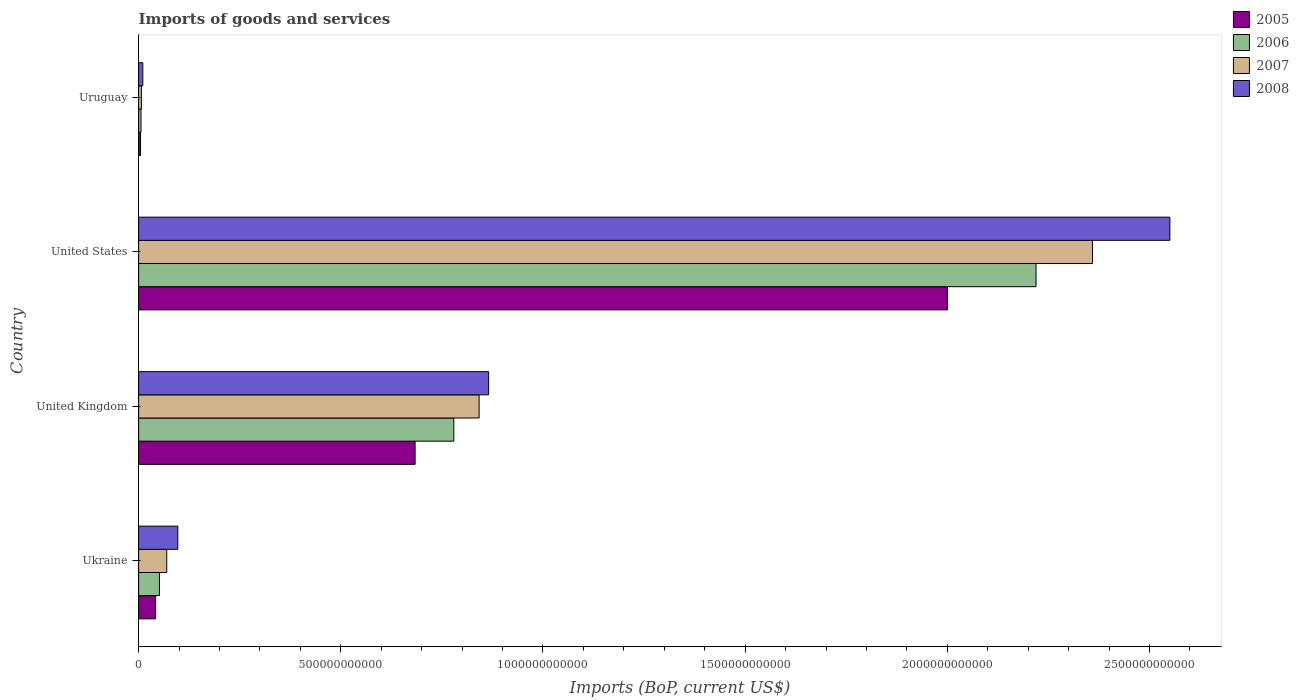How many different coloured bars are there?
Your response must be concise. 4. How many groups of bars are there?
Ensure brevity in your answer.  4. Are the number of bars on each tick of the Y-axis equal?
Your response must be concise. Yes. How many bars are there on the 1st tick from the bottom?
Your response must be concise. 4. What is the label of the 4th group of bars from the top?
Provide a succinct answer. Ukraine. What is the amount spent on imports in 2008 in United States?
Give a very brief answer. 2.55e+12. Across all countries, what is the maximum amount spent on imports in 2005?
Keep it short and to the point. 2.00e+12. Across all countries, what is the minimum amount spent on imports in 2005?
Keep it short and to the point. 4.69e+09. In which country was the amount spent on imports in 2007 maximum?
Your response must be concise. United States. In which country was the amount spent on imports in 2005 minimum?
Give a very brief answer. Uruguay. What is the total amount spent on imports in 2006 in the graph?
Give a very brief answer. 3.06e+12. What is the difference between the amount spent on imports in 2005 in United Kingdom and that in Uruguay?
Give a very brief answer. 6.79e+11. What is the difference between the amount spent on imports in 2005 in United States and the amount spent on imports in 2006 in Uruguay?
Your answer should be compact. 1.99e+12. What is the average amount spent on imports in 2006 per country?
Your answer should be compact. 7.64e+11. What is the difference between the amount spent on imports in 2005 and amount spent on imports in 2006 in Uruguay?
Your answer should be compact. -1.18e+09. What is the ratio of the amount spent on imports in 2005 in Ukraine to that in United States?
Keep it short and to the point. 0.02. What is the difference between the highest and the second highest amount spent on imports in 2006?
Provide a succinct answer. 1.44e+12. What is the difference between the highest and the lowest amount spent on imports in 2007?
Your answer should be compact. 2.35e+12. In how many countries, is the amount spent on imports in 2007 greater than the average amount spent on imports in 2007 taken over all countries?
Offer a terse response. 2. What does the 4th bar from the bottom in Ukraine represents?
Your response must be concise. 2008. Is it the case that in every country, the sum of the amount spent on imports in 2005 and amount spent on imports in 2008 is greater than the amount spent on imports in 2007?
Ensure brevity in your answer.  Yes. Are all the bars in the graph horizontal?
Your answer should be compact. Yes. How many countries are there in the graph?
Offer a terse response. 4. What is the difference between two consecutive major ticks on the X-axis?
Your answer should be very brief. 5.00e+11. Are the values on the major ticks of X-axis written in scientific E-notation?
Make the answer very short. No. How many legend labels are there?
Provide a succinct answer. 4. How are the legend labels stacked?
Your answer should be compact. Vertical. What is the title of the graph?
Your answer should be very brief. Imports of goods and services. What is the label or title of the X-axis?
Offer a terse response. Imports (BoP, current US$). What is the label or title of the Y-axis?
Your response must be concise. Country. What is the Imports (BoP, current US$) in 2005 in Ukraine?
Your answer should be compact. 4.20e+1. What is the Imports (BoP, current US$) in 2006 in Ukraine?
Provide a succinct answer. 5.14e+1. What is the Imports (BoP, current US$) in 2007 in Ukraine?
Keep it short and to the point. 6.95e+1. What is the Imports (BoP, current US$) of 2008 in Ukraine?
Provide a short and direct response. 9.68e+1. What is the Imports (BoP, current US$) of 2005 in United Kingdom?
Offer a very short reply. 6.84e+11. What is the Imports (BoP, current US$) in 2006 in United Kingdom?
Offer a very short reply. 7.80e+11. What is the Imports (BoP, current US$) of 2007 in United Kingdom?
Offer a terse response. 8.42e+11. What is the Imports (BoP, current US$) in 2008 in United Kingdom?
Provide a short and direct response. 8.66e+11. What is the Imports (BoP, current US$) of 2005 in United States?
Provide a succinct answer. 2.00e+12. What is the Imports (BoP, current US$) of 2006 in United States?
Give a very brief answer. 2.22e+12. What is the Imports (BoP, current US$) in 2007 in United States?
Provide a short and direct response. 2.36e+12. What is the Imports (BoP, current US$) of 2008 in United States?
Offer a very short reply. 2.55e+12. What is the Imports (BoP, current US$) in 2005 in Uruguay?
Ensure brevity in your answer.  4.69e+09. What is the Imports (BoP, current US$) in 2006 in Uruguay?
Offer a terse response. 5.88e+09. What is the Imports (BoP, current US$) of 2007 in Uruguay?
Keep it short and to the point. 6.78e+09. What is the Imports (BoP, current US$) in 2008 in Uruguay?
Provide a short and direct response. 1.03e+1. Across all countries, what is the maximum Imports (BoP, current US$) in 2005?
Your answer should be compact. 2.00e+12. Across all countries, what is the maximum Imports (BoP, current US$) of 2006?
Your answer should be very brief. 2.22e+12. Across all countries, what is the maximum Imports (BoP, current US$) in 2007?
Offer a terse response. 2.36e+12. Across all countries, what is the maximum Imports (BoP, current US$) in 2008?
Your answer should be compact. 2.55e+12. Across all countries, what is the minimum Imports (BoP, current US$) of 2005?
Your answer should be compact. 4.69e+09. Across all countries, what is the minimum Imports (BoP, current US$) in 2006?
Give a very brief answer. 5.88e+09. Across all countries, what is the minimum Imports (BoP, current US$) in 2007?
Your response must be concise. 6.78e+09. Across all countries, what is the minimum Imports (BoP, current US$) in 2008?
Provide a short and direct response. 1.03e+1. What is the total Imports (BoP, current US$) in 2005 in the graph?
Your answer should be very brief. 2.73e+12. What is the total Imports (BoP, current US$) in 2006 in the graph?
Offer a very short reply. 3.06e+12. What is the total Imports (BoP, current US$) of 2007 in the graph?
Provide a succinct answer. 3.28e+12. What is the total Imports (BoP, current US$) of 2008 in the graph?
Offer a terse response. 3.52e+12. What is the difference between the Imports (BoP, current US$) of 2005 in Ukraine and that in United Kingdom?
Keep it short and to the point. -6.42e+11. What is the difference between the Imports (BoP, current US$) of 2006 in Ukraine and that in United Kingdom?
Give a very brief answer. -7.28e+11. What is the difference between the Imports (BoP, current US$) of 2007 in Ukraine and that in United Kingdom?
Give a very brief answer. -7.72e+11. What is the difference between the Imports (BoP, current US$) of 2008 in Ukraine and that in United Kingdom?
Keep it short and to the point. -7.69e+11. What is the difference between the Imports (BoP, current US$) in 2005 in Ukraine and that in United States?
Offer a very short reply. -1.96e+12. What is the difference between the Imports (BoP, current US$) of 2006 in Ukraine and that in United States?
Offer a terse response. -2.17e+12. What is the difference between the Imports (BoP, current US$) in 2007 in Ukraine and that in United States?
Provide a succinct answer. -2.29e+12. What is the difference between the Imports (BoP, current US$) of 2008 in Ukraine and that in United States?
Give a very brief answer. -2.45e+12. What is the difference between the Imports (BoP, current US$) of 2005 in Ukraine and that in Uruguay?
Provide a succinct answer. 3.73e+1. What is the difference between the Imports (BoP, current US$) in 2006 in Ukraine and that in Uruguay?
Make the answer very short. 4.55e+1. What is the difference between the Imports (BoP, current US$) in 2007 in Ukraine and that in Uruguay?
Ensure brevity in your answer.  6.28e+1. What is the difference between the Imports (BoP, current US$) in 2008 in Ukraine and that in Uruguay?
Your response must be concise. 8.65e+1. What is the difference between the Imports (BoP, current US$) of 2005 in United Kingdom and that in United States?
Your answer should be very brief. -1.32e+12. What is the difference between the Imports (BoP, current US$) in 2006 in United Kingdom and that in United States?
Provide a succinct answer. -1.44e+12. What is the difference between the Imports (BoP, current US$) of 2007 in United Kingdom and that in United States?
Offer a very short reply. -1.52e+12. What is the difference between the Imports (BoP, current US$) in 2008 in United Kingdom and that in United States?
Offer a terse response. -1.68e+12. What is the difference between the Imports (BoP, current US$) in 2005 in United Kingdom and that in Uruguay?
Keep it short and to the point. 6.79e+11. What is the difference between the Imports (BoP, current US$) of 2006 in United Kingdom and that in Uruguay?
Provide a succinct answer. 7.74e+11. What is the difference between the Imports (BoP, current US$) of 2007 in United Kingdom and that in Uruguay?
Offer a very short reply. 8.35e+11. What is the difference between the Imports (BoP, current US$) in 2008 in United Kingdom and that in Uruguay?
Offer a terse response. 8.55e+11. What is the difference between the Imports (BoP, current US$) in 2005 in United States and that in Uruguay?
Provide a succinct answer. 2.00e+12. What is the difference between the Imports (BoP, current US$) in 2006 in United States and that in Uruguay?
Your answer should be very brief. 2.21e+12. What is the difference between the Imports (BoP, current US$) in 2007 in United States and that in Uruguay?
Keep it short and to the point. 2.35e+12. What is the difference between the Imports (BoP, current US$) in 2008 in United States and that in Uruguay?
Provide a short and direct response. 2.54e+12. What is the difference between the Imports (BoP, current US$) in 2005 in Ukraine and the Imports (BoP, current US$) in 2006 in United Kingdom?
Make the answer very short. -7.38e+11. What is the difference between the Imports (BoP, current US$) in 2005 in Ukraine and the Imports (BoP, current US$) in 2007 in United Kingdom?
Offer a terse response. -8.00e+11. What is the difference between the Imports (BoP, current US$) in 2005 in Ukraine and the Imports (BoP, current US$) in 2008 in United Kingdom?
Offer a very short reply. -8.24e+11. What is the difference between the Imports (BoP, current US$) of 2006 in Ukraine and the Imports (BoP, current US$) of 2007 in United Kingdom?
Offer a terse response. -7.91e+11. What is the difference between the Imports (BoP, current US$) of 2006 in Ukraine and the Imports (BoP, current US$) of 2008 in United Kingdom?
Your answer should be compact. -8.14e+11. What is the difference between the Imports (BoP, current US$) of 2007 in Ukraine and the Imports (BoP, current US$) of 2008 in United Kingdom?
Offer a terse response. -7.96e+11. What is the difference between the Imports (BoP, current US$) in 2005 in Ukraine and the Imports (BoP, current US$) in 2006 in United States?
Give a very brief answer. -2.18e+12. What is the difference between the Imports (BoP, current US$) of 2005 in Ukraine and the Imports (BoP, current US$) of 2007 in United States?
Give a very brief answer. -2.32e+12. What is the difference between the Imports (BoP, current US$) in 2005 in Ukraine and the Imports (BoP, current US$) in 2008 in United States?
Give a very brief answer. -2.51e+12. What is the difference between the Imports (BoP, current US$) of 2006 in Ukraine and the Imports (BoP, current US$) of 2007 in United States?
Provide a short and direct response. -2.31e+12. What is the difference between the Imports (BoP, current US$) in 2006 in Ukraine and the Imports (BoP, current US$) in 2008 in United States?
Your response must be concise. -2.50e+12. What is the difference between the Imports (BoP, current US$) in 2007 in Ukraine and the Imports (BoP, current US$) in 2008 in United States?
Ensure brevity in your answer.  -2.48e+12. What is the difference between the Imports (BoP, current US$) of 2005 in Ukraine and the Imports (BoP, current US$) of 2006 in Uruguay?
Offer a very short reply. 3.61e+1. What is the difference between the Imports (BoP, current US$) in 2005 in Ukraine and the Imports (BoP, current US$) in 2007 in Uruguay?
Offer a very short reply. 3.52e+1. What is the difference between the Imports (BoP, current US$) of 2005 in Ukraine and the Imports (BoP, current US$) of 2008 in Uruguay?
Your response must be concise. 3.16e+1. What is the difference between the Imports (BoP, current US$) of 2006 in Ukraine and the Imports (BoP, current US$) of 2007 in Uruguay?
Provide a succinct answer. 4.46e+1. What is the difference between the Imports (BoP, current US$) in 2006 in Ukraine and the Imports (BoP, current US$) in 2008 in Uruguay?
Your answer should be very brief. 4.11e+1. What is the difference between the Imports (BoP, current US$) of 2007 in Ukraine and the Imports (BoP, current US$) of 2008 in Uruguay?
Your answer should be very brief. 5.92e+1. What is the difference between the Imports (BoP, current US$) in 2005 in United Kingdom and the Imports (BoP, current US$) in 2006 in United States?
Make the answer very short. -1.54e+12. What is the difference between the Imports (BoP, current US$) of 2005 in United Kingdom and the Imports (BoP, current US$) of 2007 in United States?
Offer a very short reply. -1.68e+12. What is the difference between the Imports (BoP, current US$) in 2005 in United Kingdom and the Imports (BoP, current US$) in 2008 in United States?
Provide a short and direct response. -1.87e+12. What is the difference between the Imports (BoP, current US$) in 2006 in United Kingdom and the Imports (BoP, current US$) in 2007 in United States?
Your answer should be very brief. -1.58e+12. What is the difference between the Imports (BoP, current US$) of 2006 in United Kingdom and the Imports (BoP, current US$) of 2008 in United States?
Offer a terse response. -1.77e+12. What is the difference between the Imports (BoP, current US$) of 2007 in United Kingdom and the Imports (BoP, current US$) of 2008 in United States?
Keep it short and to the point. -1.71e+12. What is the difference between the Imports (BoP, current US$) of 2005 in United Kingdom and the Imports (BoP, current US$) of 2006 in Uruguay?
Provide a succinct answer. 6.78e+11. What is the difference between the Imports (BoP, current US$) in 2005 in United Kingdom and the Imports (BoP, current US$) in 2007 in Uruguay?
Offer a very short reply. 6.77e+11. What is the difference between the Imports (BoP, current US$) in 2005 in United Kingdom and the Imports (BoP, current US$) in 2008 in Uruguay?
Your response must be concise. 6.73e+11. What is the difference between the Imports (BoP, current US$) in 2006 in United Kingdom and the Imports (BoP, current US$) in 2007 in Uruguay?
Provide a succinct answer. 7.73e+11. What is the difference between the Imports (BoP, current US$) in 2006 in United Kingdom and the Imports (BoP, current US$) in 2008 in Uruguay?
Keep it short and to the point. 7.69e+11. What is the difference between the Imports (BoP, current US$) in 2007 in United Kingdom and the Imports (BoP, current US$) in 2008 in Uruguay?
Your answer should be very brief. 8.32e+11. What is the difference between the Imports (BoP, current US$) in 2005 in United States and the Imports (BoP, current US$) in 2006 in Uruguay?
Provide a short and direct response. 1.99e+12. What is the difference between the Imports (BoP, current US$) of 2005 in United States and the Imports (BoP, current US$) of 2007 in Uruguay?
Your response must be concise. 1.99e+12. What is the difference between the Imports (BoP, current US$) of 2005 in United States and the Imports (BoP, current US$) of 2008 in Uruguay?
Provide a short and direct response. 1.99e+12. What is the difference between the Imports (BoP, current US$) in 2006 in United States and the Imports (BoP, current US$) in 2007 in Uruguay?
Make the answer very short. 2.21e+12. What is the difference between the Imports (BoP, current US$) in 2006 in United States and the Imports (BoP, current US$) in 2008 in Uruguay?
Provide a short and direct response. 2.21e+12. What is the difference between the Imports (BoP, current US$) in 2007 in United States and the Imports (BoP, current US$) in 2008 in Uruguay?
Offer a terse response. 2.35e+12. What is the average Imports (BoP, current US$) of 2005 per country?
Make the answer very short. 6.83e+11. What is the average Imports (BoP, current US$) in 2006 per country?
Make the answer very short. 7.64e+11. What is the average Imports (BoP, current US$) in 2007 per country?
Provide a short and direct response. 8.19e+11. What is the average Imports (BoP, current US$) of 2008 per country?
Offer a terse response. 8.81e+11. What is the difference between the Imports (BoP, current US$) of 2005 and Imports (BoP, current US$) of 2006 in Ukraine?
Your answer should be very brief. -9.47e+09. What is the difference between the Imports (BoP, current US$) of 2005 and Imports (BoP, current US$) of 2007 in Ukraine?
Give a very brief answer. -2.76e+1. What is the difference between the Imports (BoP, current US$) of 2005 and Imports (BoP, current US$) of 2008 in Ukraine?
Your answer should be compact. -5.49e+1. What is the difference between the Imports (BoP, current US$) in 2006 and Imports (BoP, current US$) in 2007 in Ukraine?
Keep it short and to the point. -1.81e+1. What is the difference between the Imports (BoP, current US$) of 2006 and Imports (BoP, current US$) of 2008 in Ukraine?
Offer a very short reply. -4.54e+1. What is the difference between the Imports (BoP, current US$) of 2007 and Imports (BoP, current US$) of 2008 in Ukraine?
Your answer should be compact. -2.73e+1. What is the difference between the Imports (BoP, current US$) in 2005 and Imports (BoP, current US$) in 2006 in United Kingdom?
Give a very brief answer. -9.58e+1. What is the difference between the Imports (BoP, current US$) of 2005 and Imports (BoP, current US$) of 2007 in United Kingdom?
Provide a short and direct response. -1.58e+11. What is the difference between the Imports (BoP, current US$) of 2005 and Imports (BoP, current US$) of 2008 in United Kingdom?
Your answer should be very brief. -1.82e+11. What is the difference between the Imports (BoP, current US$) of 2006 and Imports (BoP, current US$) of 2007 in United Kingdom?
Your response must be concise. -6.25e+1. What is the difference between the Imports (BoP, current US$) in 2006 and Imports (BoP, current US$) in 2008 in United Kingdom?
Ensure brevity in your answer.  -8.61e+1. What is the difference between the Imports (BoP, current US$) in 2007 and Imports (BoP, current US$) in 2008 in United Kingdom?
Provide a short and direct response. -2.36e+1. What is the difference between the Imports (BoP, current US$) in 2005 and Imports (BoP, current US$) in 2006 in United States?
Keep it short and to the point. -2.19e+11. What is the difference between the Imports (BoP, current US$) in 2005 and Imports (BoP, current US$) in 2007 in United States?
Ensure brevity in your answer.  -3.59e+11. What is the difference between the Imports (BoP, current US$) in 2005 and Imports (BoP, current US$) in 2008 in United States?
Make the answer very short. -5.50e+11. What is the difference between the Imports (BoP, current US$) of 2006 and Imports (BoP, current US$) of 2007 in United States?
Your answer should be compact. -1.40e+11. What is the difference between the Imports (BoP, current US$) of 2006 and Imports (BoP, current US$) of 2008 in United States?
Your answer should be very brief. -3.31e+11. What is the difference between the Imports (BoP, current US$) of 2007 and Imports (BoP, current US$) of 2008 in United States?
Make the answer very short. -1.91e+11. What is the difference between the Imports (BoP, current US$) in 2005 and Imports (BoP, current US$) in 2006 in Uruguay?
Keep it short and to the point. -1.18e+09. What is the difference between the Imports (BoP, current US$) in 2005 and Imports (BoP, current US$) in 2007 in Uruguay?
Offer a very short reply. -2.08e+09. What is the difference between the Imports (BoP, current US$) in 2005 and Imports (BoP, current US$) in 2008 in Uruguay?
Your response must be concise. -5.64e+09. What is the difference between the Imports (BoP, current US$) of 2006 and Imports (BoP, current US$) of 2007 in Uruguay?
Your response must be concise. -8.98e+08. What is the difference between the Imports (BoP, current US$) in 2006 and Imports (BoP, current US$) in 2008 in Uruguay?
Provide a short and direct response. -4.46e+09. What is the difference between the Imports (BoP, current US$) in 2007 and Imports (BoP, current US$) in 2008 in Uruguay?
Your response must be concise. -3.56e+09. What is the ratio of the Imports (BoP, current US$) of 2005 in Ukraine to that in United Kingdom?
Your response must be concise. 0.06. What is the ratio of the Imports (BoP, current US$) of 2006 in Ukraine to that in United Kingdom?
Make the answer very short. 0.07. What is the ratio of the Imports (BoP, current US$) of 2007 in Ukraine to that in United Kingdom?
Offer a very short reply. 0.08. What is the ratio of the Imports (BoP, current US$) in 2008 in Ukraine to that in United Kingdom?
Keep it short and to the point. 0.11. What is the ratio of the Imports (BoP, current US$) of 2005 in Ukraine to that in United States?
Give a very brief answer. 0.02. What is the ratio of the Imports (BoP, current US$) in 2006 in Ukraine to that in United States?
Offer a terse response. 0.02. What is the ratio of the Imports (BoP, current US$) of 2007 in Ukraine to that in United States?
Make the answer very short. 0.03. What is the ratio of the Imports (BoP, current US$) in 2008 in Ukraine to that in United States?
Offer a terse response. 0.04. What is the ratio of the Imports (BoP, current US$) in 2005 in Ukraine to that in Uruguay?
Offer a terse response. 8.94. What is the ratio of the Imports (BoP, current US$) of 2006 in Ukraine to that in Uruguay?
Make the answer very short. 8.75. What is the ratio of the Imports (BoP, current US$) in 2007 in Ukraine to that in Uruguay?
Ensure brevity in your answer.  10.26. What is the ratio of the Imports (BoP, current US$) of 2008 in Ukraine to that in Uruguay?
Your answer should be compact. 9.37. What is the ratio of the Imports (BoP, current US$) of 2005 in United Kingdom to that in United States?
Keep it short and to the point. 0.34. What is the ratio of the Imports (BoP, current US$) in 2006 in United Kingdom to that in United States?
Ensure brevity in your answer.  0.35. What is the ratio of the Imports (BoP, current US$) of 2007 in United Kingdom to that in United States?
Provide a succinct answer. 0.36. What is the ratio of the Imports (BoP, current US$) of 2008 in United Kingdom to that in United States?
Offer a terse response. 0.34. What is the ratio of the Imports (BoP, current US$) in 2005 in United Kingdom to that in Uruguay?
Your answer should be very brief. 145.7. What is the ratio of the Imports (BoP, current US$) in 2006 in United Kingdom to that in Uruguay?
Provide a succinct answer. 132.64. What is the ratio of the Imports (BoP, current US$) in 2007 in United Kingdom to that in Uruguay?
Your answer should be very brief. 124.28. What is the ratio of the Imports (BoP, current US$) of 2008 in United Kingdom to that in Uruguay?
Keep it short and to the point. 83.77. What is the ratio of the Imports (BoP, current US$) of 2005 in United States to that in Uruguay?
Ensure brevity in your answer.  426.25. What is the ratio of the Imports (BoP, current US$) in 2006 in United States to that in Uruguay?
Provide a short and direct response. 377.63. What is the ratio of the Imports (BoP, current US$) of 2007 in United States to that in Uruguay?
Offer a terse response. 348.16. What is the ratio of the Imports (BoP, current US$) of 2008 in United States to that in Uruguay?
Offer a very short reply. 246.81. What is the difference between the highest and the second highest Imports (BoP, current US$) in 2005?
Offer a very short reply. 1.32e+12. What is the difference between the highest and the second highest Imports (BoP, current US$) of 2006?
Provide a succinct answer. 1.44e+12. What is the difference between the highest and the second highest Imports (BoP, current US$) of 2007?
Make the answer very short. 1.52e+12. What is the difference between the highest and the second highest Imports (BoP, current US$) of 2008?
Provide a short and direct response. 1.68e+12. What is the difference between the highest and the lowest Imports (BoP, current US$) in 2005?
Offer a terse response. 2.00e+12. What is the difference between the highest and the lowest Imports (BoP, current US$) in 2006?
Offer a very short reply. 2.21e+12. What is the difference between the highest and the lowest Imports (BoP, current US$) of 2007?
Ensure brevity in your answer.  2.35e+12. What is the difference between the highest and the lowest Imports (BoP, current US$) of 2008?
Provide a succinct answer. 2.54e+12. 